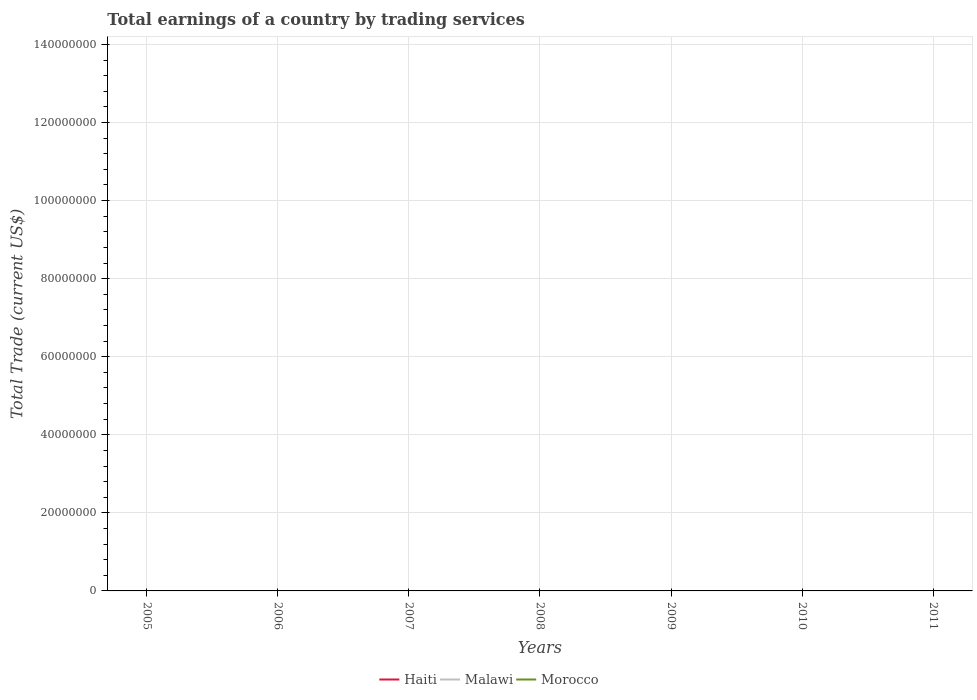Across all years, what is the maximum total earnings in Malawi?
Ensure brevity in your answer.  0. Is the total earnings in Morocco strictly greater than the total earnings in Malawi over the years?
Your response must be concise. Yes. How many years are there in the graph?
Your response must be concise. 7. What is the difference between two consecutive major ticks on the Y-axis?
Your answer should be compact. 2.00e+07. Does the graph contain grids?
Offer a very short reply. Yes. Where does the legend appear in the graph?
Ensure brevity in your answer.  Bottom center. How many legend labels are there?
Your answer should be very brief. 3. What is the title of the graph?
Offer a very short reply. Total earnings of a country by trading services. What is the label or title of the X-axis?
Your answer should be very brief. Years. What is the label or title of the Y-axis?
Your answer should be very brief. Total Trade (current US$). What is the Total Trade (current US$) of Malawi in 2005?
Your answer should be very brief. 0. What is the Total Trade (current US$) of Morocco in 2005?
Your response must be concise. 0. What is the Total Trade (current US$) of Malawi in 2006?
Offer a terse response. 0. What is the Total Trade (current US$) of Haiti in 2007?
Offer a terse response. 0. What is the Total Trade (current US$) of Malawi in 2007?
Give a very brief answer. 0. What is the Total Trade (current US$) in Morocco in 2007?
Your answer should be very brief. 0. What is the Total Trade (current US$) in Haiti in 2008?
Ensure brevity in your answer.  0. What is the Total Trade (current US$) in Morocco in 2008?
Offer a terse response. 0. What is the Total Trade (current US$) of Haiti in 2009?
Keep it short and to the point. 0. What is the Total Trade (current US$) in Malawi in 2009?
Make the answer very short. 0. What is the Total Trade (current US$) of Morocco in 2009?
Offer a very short reply. 0. What is the Total Trade (current US$) of Haiti in 2010?
Your response must be concise. 0. What is the Total Trade (current US$) in Morocco in 2010?
Make the answer very short. 0. What is the Total Trade (current US$) of Morocco in 2011?
Provide a short and direct response. 0. What is the total Total Trade (current US$) in Haiti in the graph?
Make the answer very short. 0. What is the total Total Trade (current US$) in Malawi in the graph?
Make the answer very short. 0. What is the average Total Trade (current US$) of Haiti per year?
Ensure brevity in your answer.  0. 